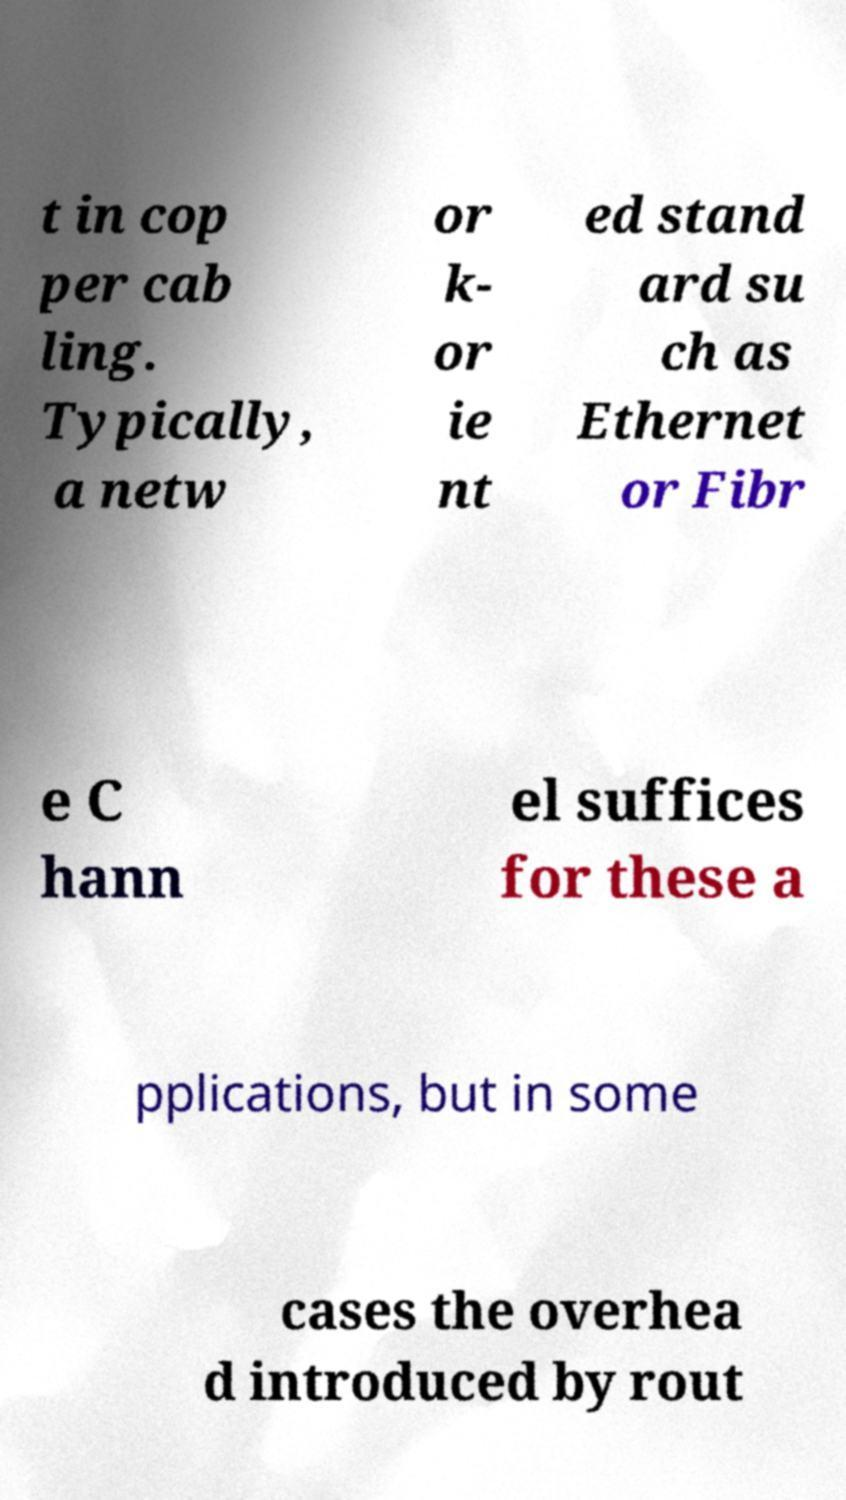For documentation purposes, I need the text within this image transcribed. Could you provide that? t in cop per cab ling. Typically, a netw or k- or ie nt ed stand ard su ch as Ethernet or Fibr e C hann el suffices for these a pplications, but in some cases the overhea d introduced by rout 